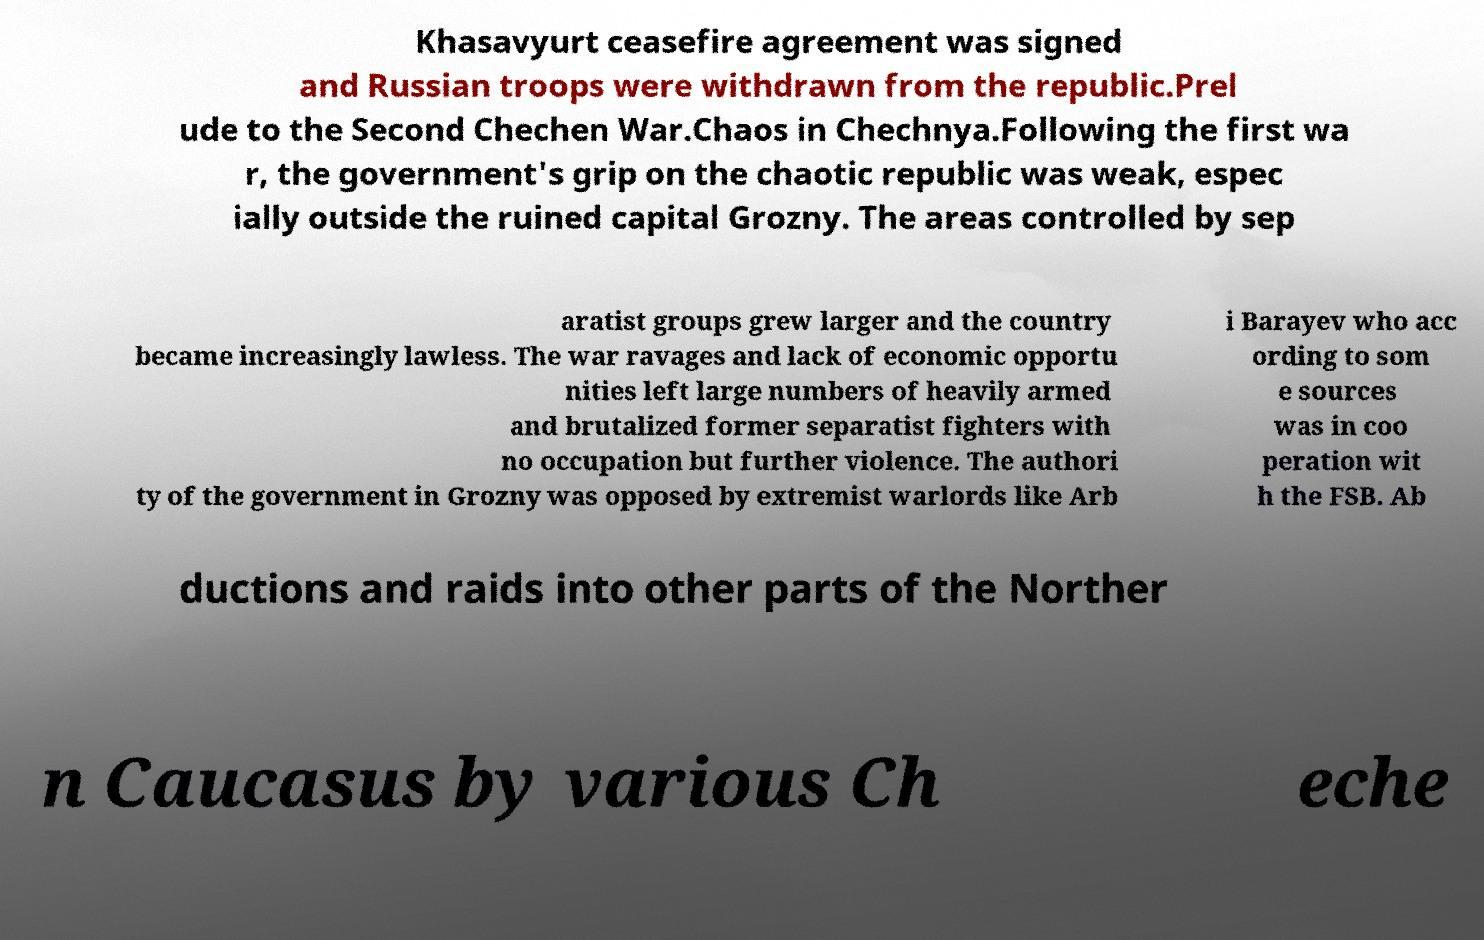What messages or text are displayed in this image? I need them in a readable, typed format. Khasavyurt ceasefire agreement was signed and Russian troops were withdrawn from the republic.Prel ude to the Second Chechen War.Chaos in Chechnya.Following the first wa r, the government's grip on the chaotic republic was weak, espec ially outside the ruined capital Grozny. The areas controlled by sep aratist groups grew larger and the country became increasingly lawless. The war ravages and lack of economic opportu nities left large numbers of heavily armed and brutalized former separatist fighters with no occupation but further violence. The authori ty of the government in Grozny was opposed by extremist warlords like Arb i Barayev who acc ording to som e sources was in coo peration wit h the FSB. Ab ductions and raids into other parts of the Norther n Caucasus by various Ch eche 